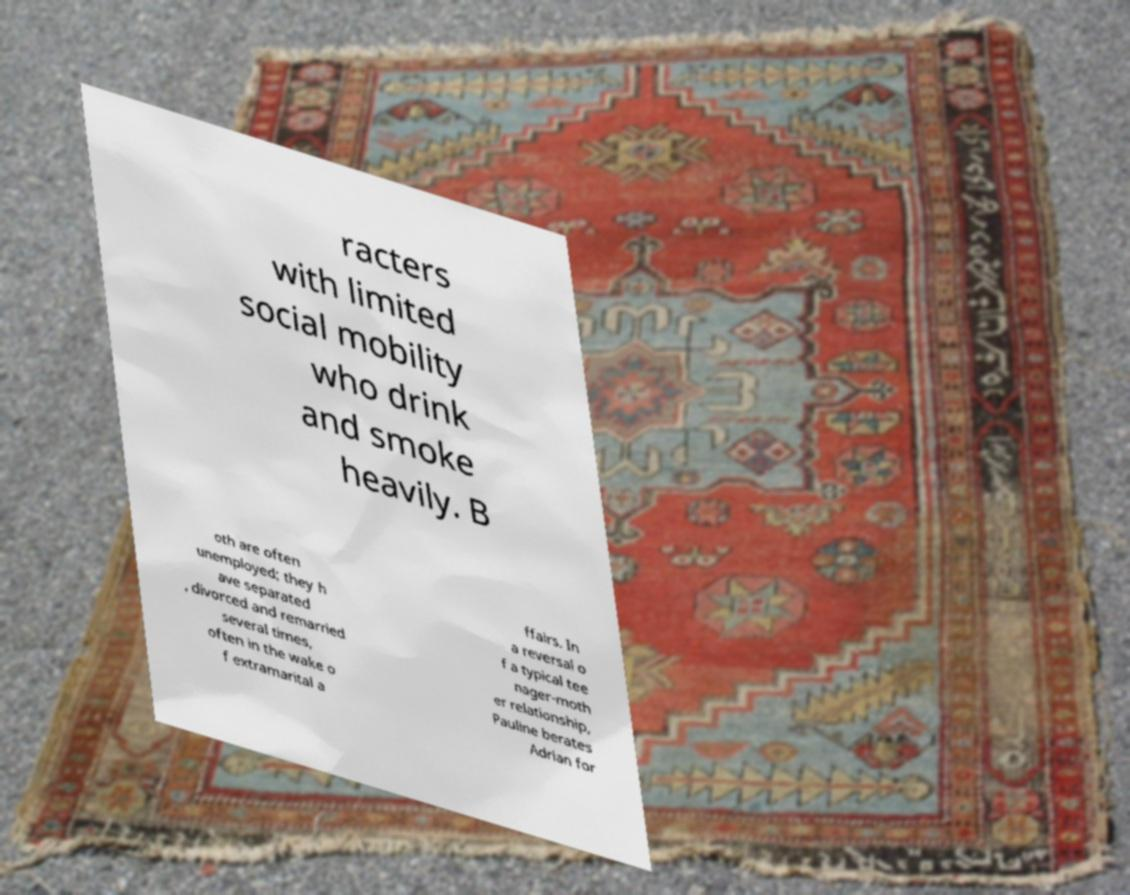For documentation purposes, I need the text within this image transcribed. Could you provide that? racters with limited social mobility who drink and smoke heavily. B oth are often unemployed; they h ave separated , divorced and remarried several times, often in the wake o f extramarital a ffairs. In a reversal o f a typical tee nager-moth er relationship, Pauline berates Adrian for 